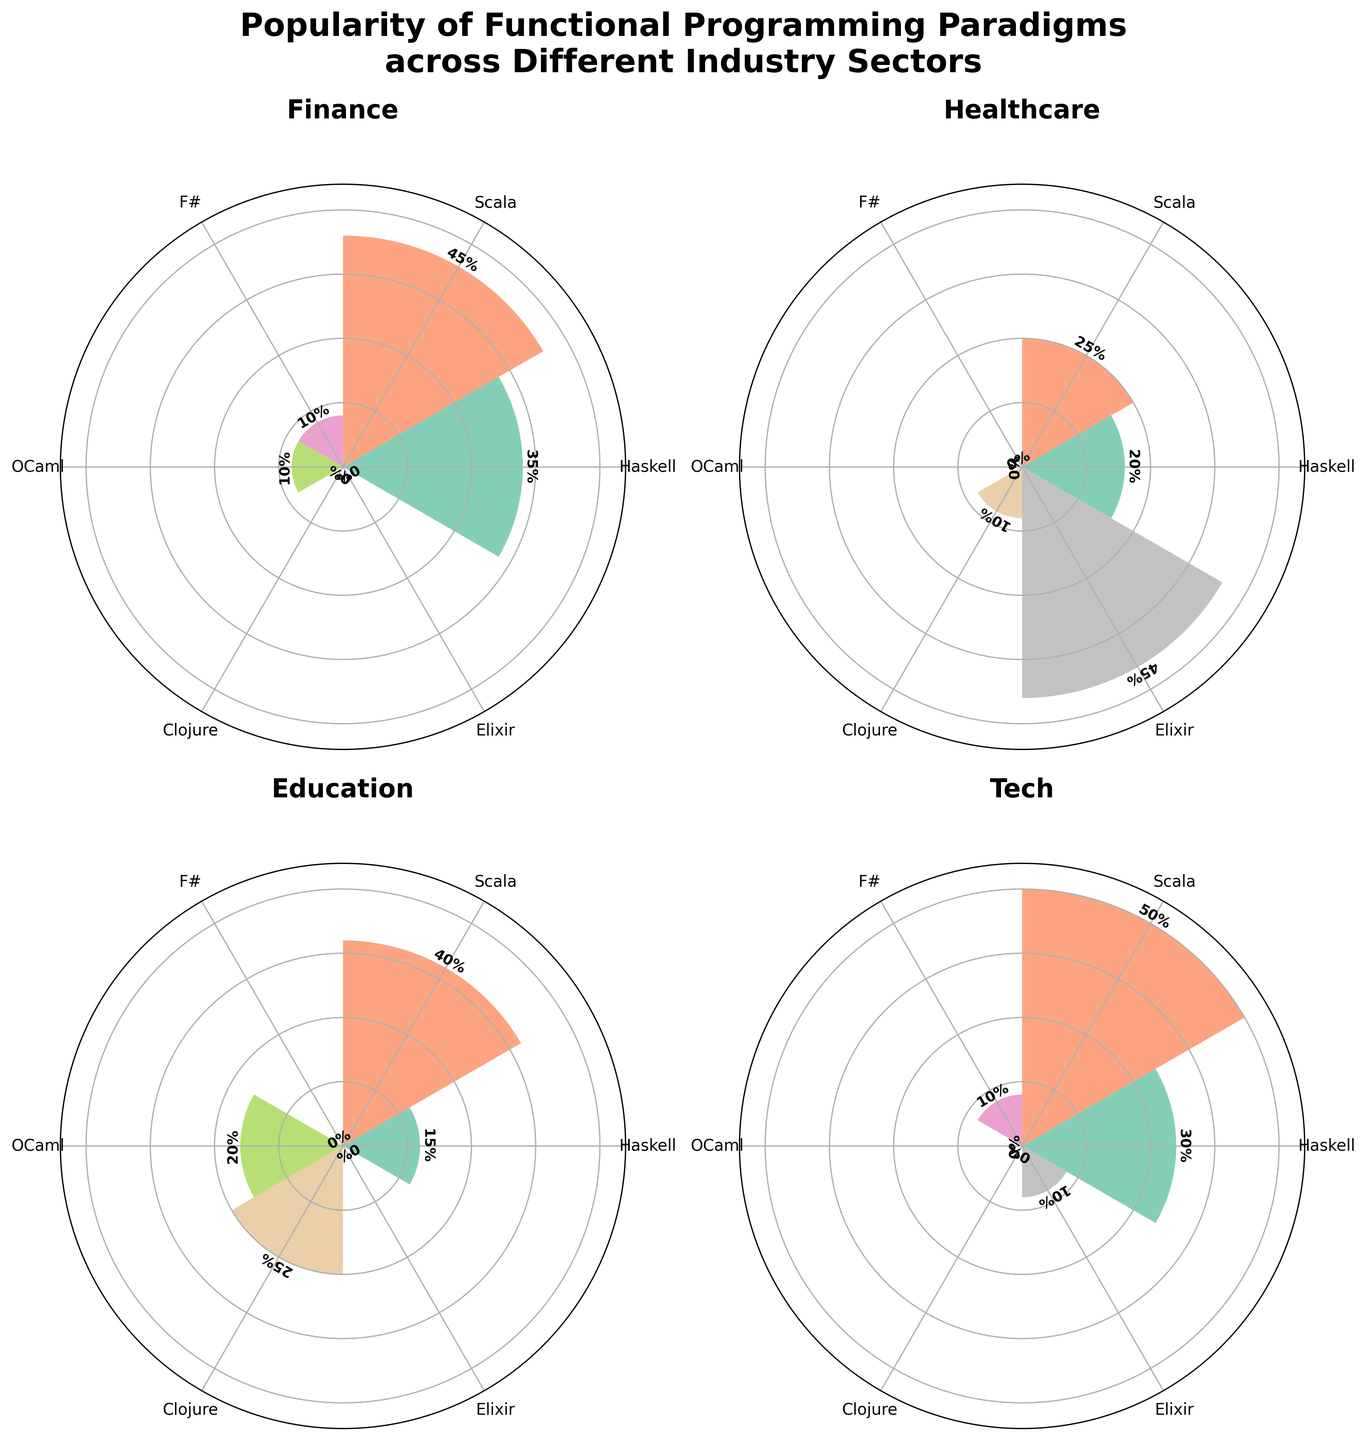What is the title of the figure? The title is displayed at the top of the figure. It reads "Popularity of Functional Programming Paradigms across Different Industry Sectors" in bold font.
Answer: Popularity of Functional Programming Paradigms across Different Industry Sectors Which industry has the highest popularity for Scala? Looking at the figure, check the sector where the bar corresponding to Scala is the highest. In the Tech subplot, the height of the Scala bar is 50%, which is the tallest among all sectors.
Answer: Tech What is the popularity difference between Haskell and Scala in the Finance sector? In the Finance subplot, the height for Haskell is 35%, and for Scala, it is 45%. The difference is calculated as 45% - 35% = 10%.
Answer: 10% Which functional programming paradigm is the least popular in the Education sector? In the Education subplot, the shortest bar corresponds to Haskell, which has a height of 15%.
Answer: Haskell Sum the popularity of all functional programming paradigms in the Healthcare sector. In the Healthcare subplot, the bars' heights are 20% (Haskell), 25% (Scala), 10% (Clojure), and 45% (Elixir). Summing these values gives 20% + 25% + 10% + 45% = 100%.
Answer: 100% Which sector has the smallest total popularity for Haskell? By examining the Haskell bars across sectors: Finance (35%), Healthcare (20%), Education (15%), Tech (30%), the smallest height is seen in the Education sector with 15%.
Answer: Education Compare the popularity of F# in Finance and Elixir in Tech. Which one is higher? In the Finance subplot, F# has a height of 10%. In the Tech subplot, Elixir also has a height of 10%. Both have the same popularity.
Answer: Equal Which sector shows the highest total use of all listed paradigms combined? Calculate the total height of all bars in each subplot:
- Finance: 35% + 45% + 10% + 10% = 100%
- Healthcare: 20% + 25% + 10% + 45% = 100%
- Education: 15% + 40% + 20% + 25% = 100%
- Tech: 30% + 50% + 10% + 10% = 100%
Each sector totals to 100%, so they are all equal.
Answer: All equal In the Healthcare sector, which paradigm shows the second highest popularity? In the Healthcare subplot, the height values are 20% (Haskell), 25% (Scala), 10% (Clojure), and 45% (Elixir). The second highest value is 25% which corresponds to Scala.
Answer: Scala 